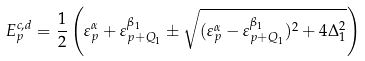<formula> <loc_0><loc_0><loc_500><loc_500>E _ { p } ^ { c , d } = \frac { 1 } { 2 } \left ( \varepsilon ^ { \alpha } _ { p } + \varepsilon ^ { \beta _ { 1 } } _ { p + Q _ { 1 } } \pm \sqrt { ( \varepsilon ^ { \alpha } _ { p } - \varepsilon ^ { \beta _ { 1 } } _ { p + Q _ { 1 } } ) ^ { 2 } + 4 \Delta _ { 1 } ^ { 2 } } \right )</formula> 